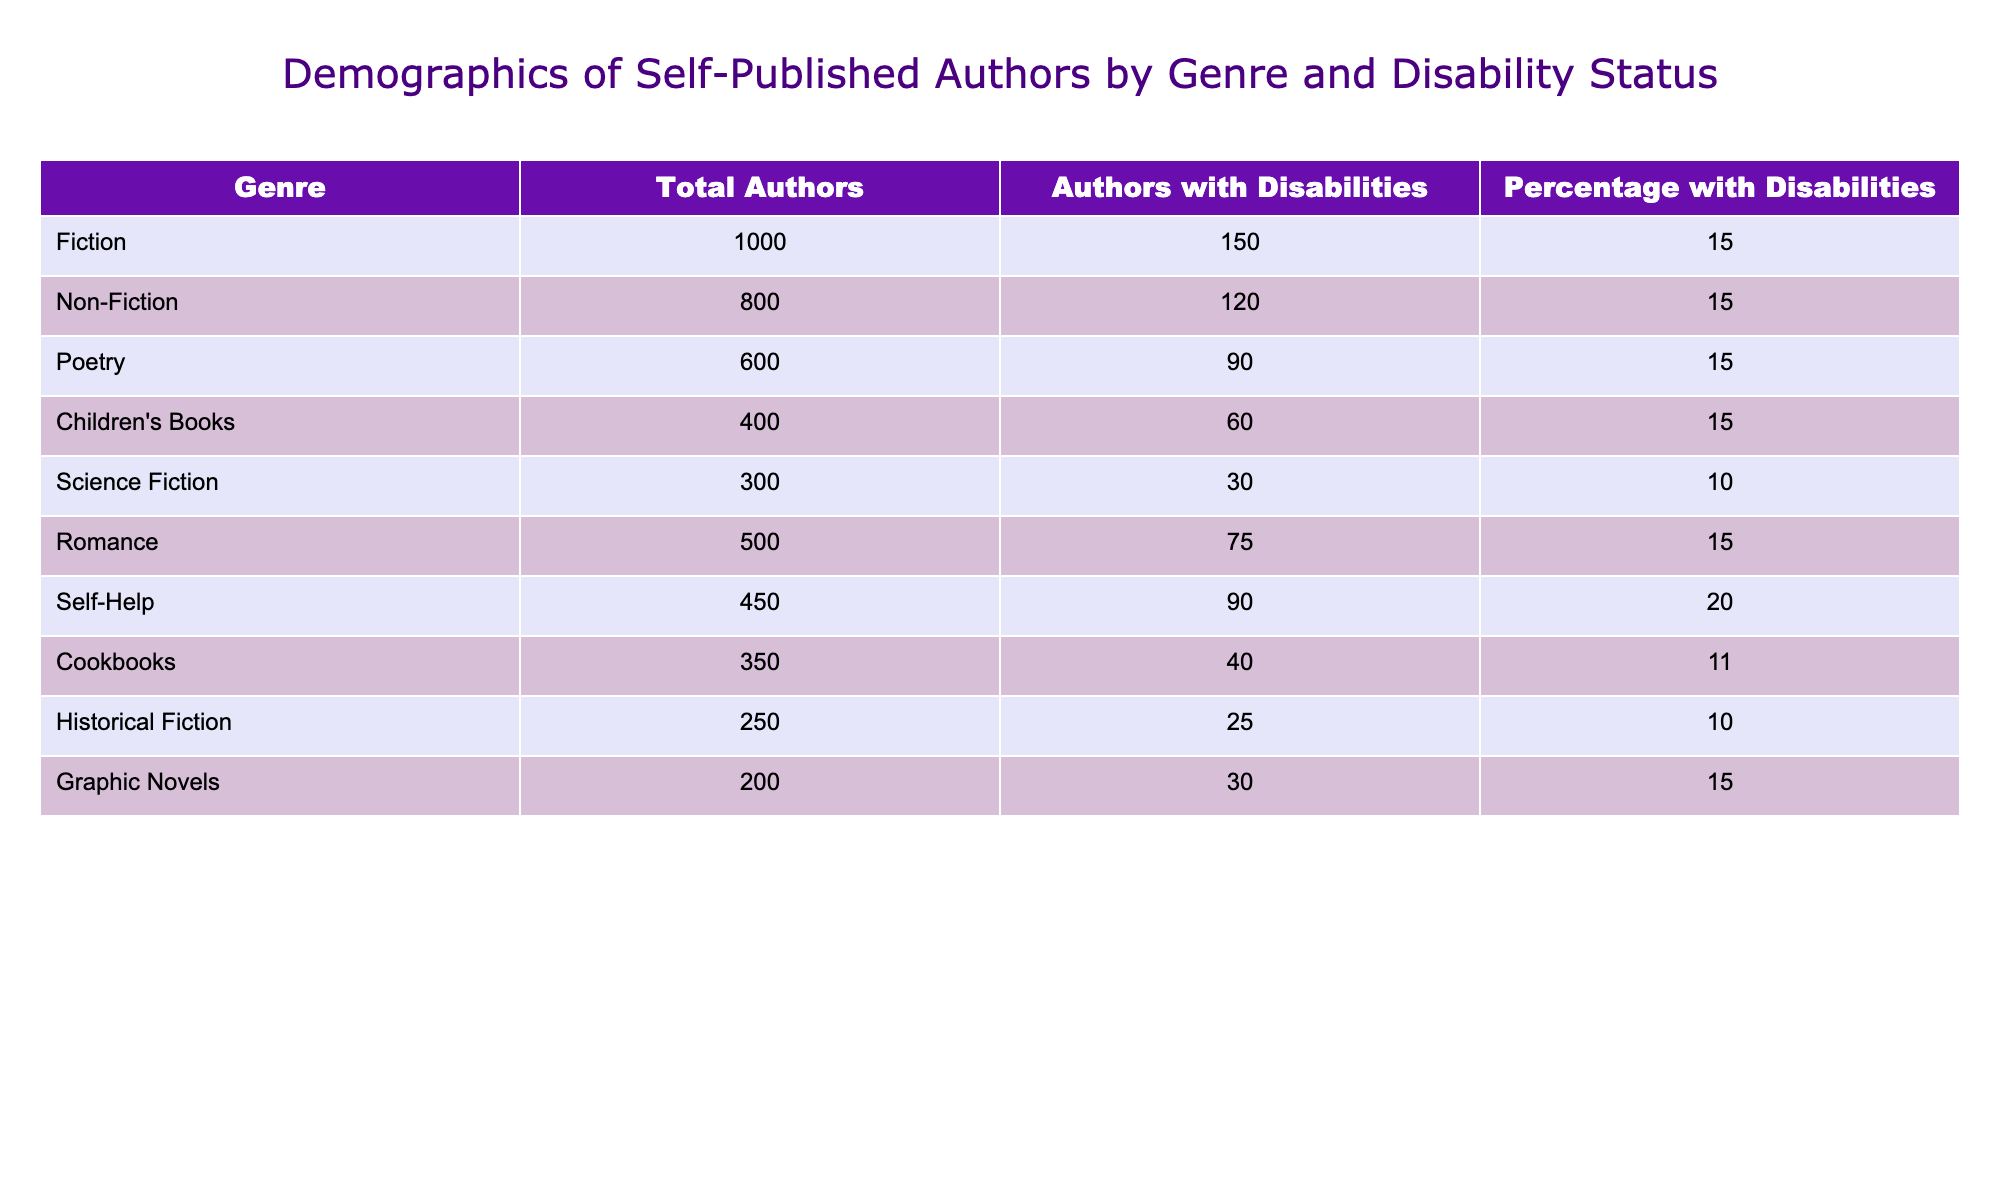What is the total number of authors in the Fiction genre? The table indicates that there are 1000 authors listed under the Fiction genre. Therefore, the total number of authors in Fiction is directly taken from the Total Authors column for that genre.
Answer: 1000 How many authors with disabilities are there in Non-Fiction? Referring to the Non-Fiction row in the table, it shows that there are 120 authors with disabilities. This is directly pulled from the Authors with Disabilities column for Non-Fiction.
Answer: 120 What percentage of authors with disabilities are in the Self-Help genre? The table shows that there are 90 authors with disabilities in the Self-Help genre. To find the percentage, we reference the total authors in the Self-Help genre, which is 450. The calculation is (90/450) * 100 = 20%.
Answer: 20% Which genre has the lowest percentage of authors with disabilities? Comparing the percentages across all genres, Science Fiction has the lowest percentage at 10%. This is confirmed by examining the Percentage with Disabilities column. The relevant row indicates it is 10%.
Answer: Science Fiction How many more authors with disabilities are there in Poetry compared to Historical Fiction? From the table, Poetry has 90 authors with disabilities, and Historical Fiction has 25. To find the difference, we subtract: 90 - 25 = 65. This shows that there are 65 more authors with disabilities in Poetry than in Historical Fiction.
Answer: 65 Is it true that the percentage of authors with disabilities in Romance is higher than in Science Fiction? The table indicates that Romance has a percentage of 15%, while Science Fiction has a percentage of 10%. Since 15% is indeed greater than 10%, the statement is true based on the comparative data found in the Percentage with Disabilities column.
Answer: Yes What is the average percentage of authors with disabilities across all genres? First, we sum the percentages of authors with disabilities from each genre: (15 + 15 + 15 + 15 + 10 + 15 + 20 + 11 + 10 + 15) = 151. There are 10 genres in total, so we divide the total by the number of genres: 151 / 10 = 15.1. Thus, the average percentage is 15.1%.
Answer: 15.1 In which genre does the number of authors with disabilities equal the total number of authors multiplied by their percentage? For each genre, we verify the relationship by calculating the expected number of authors with disabilities based on the Total Authors and the Percentage with Disabilities. For example, Fiction would be 1000 * 0.15 = 150 (equals); for Non-Fiction 800 * 0.15 = 120 (equals); for Science Fiction 300 * 0.10 = 30 (equals); each calculation matches with the actual number. By verifying each genre, we find that this holds true for each genre.
Answer: All genres 